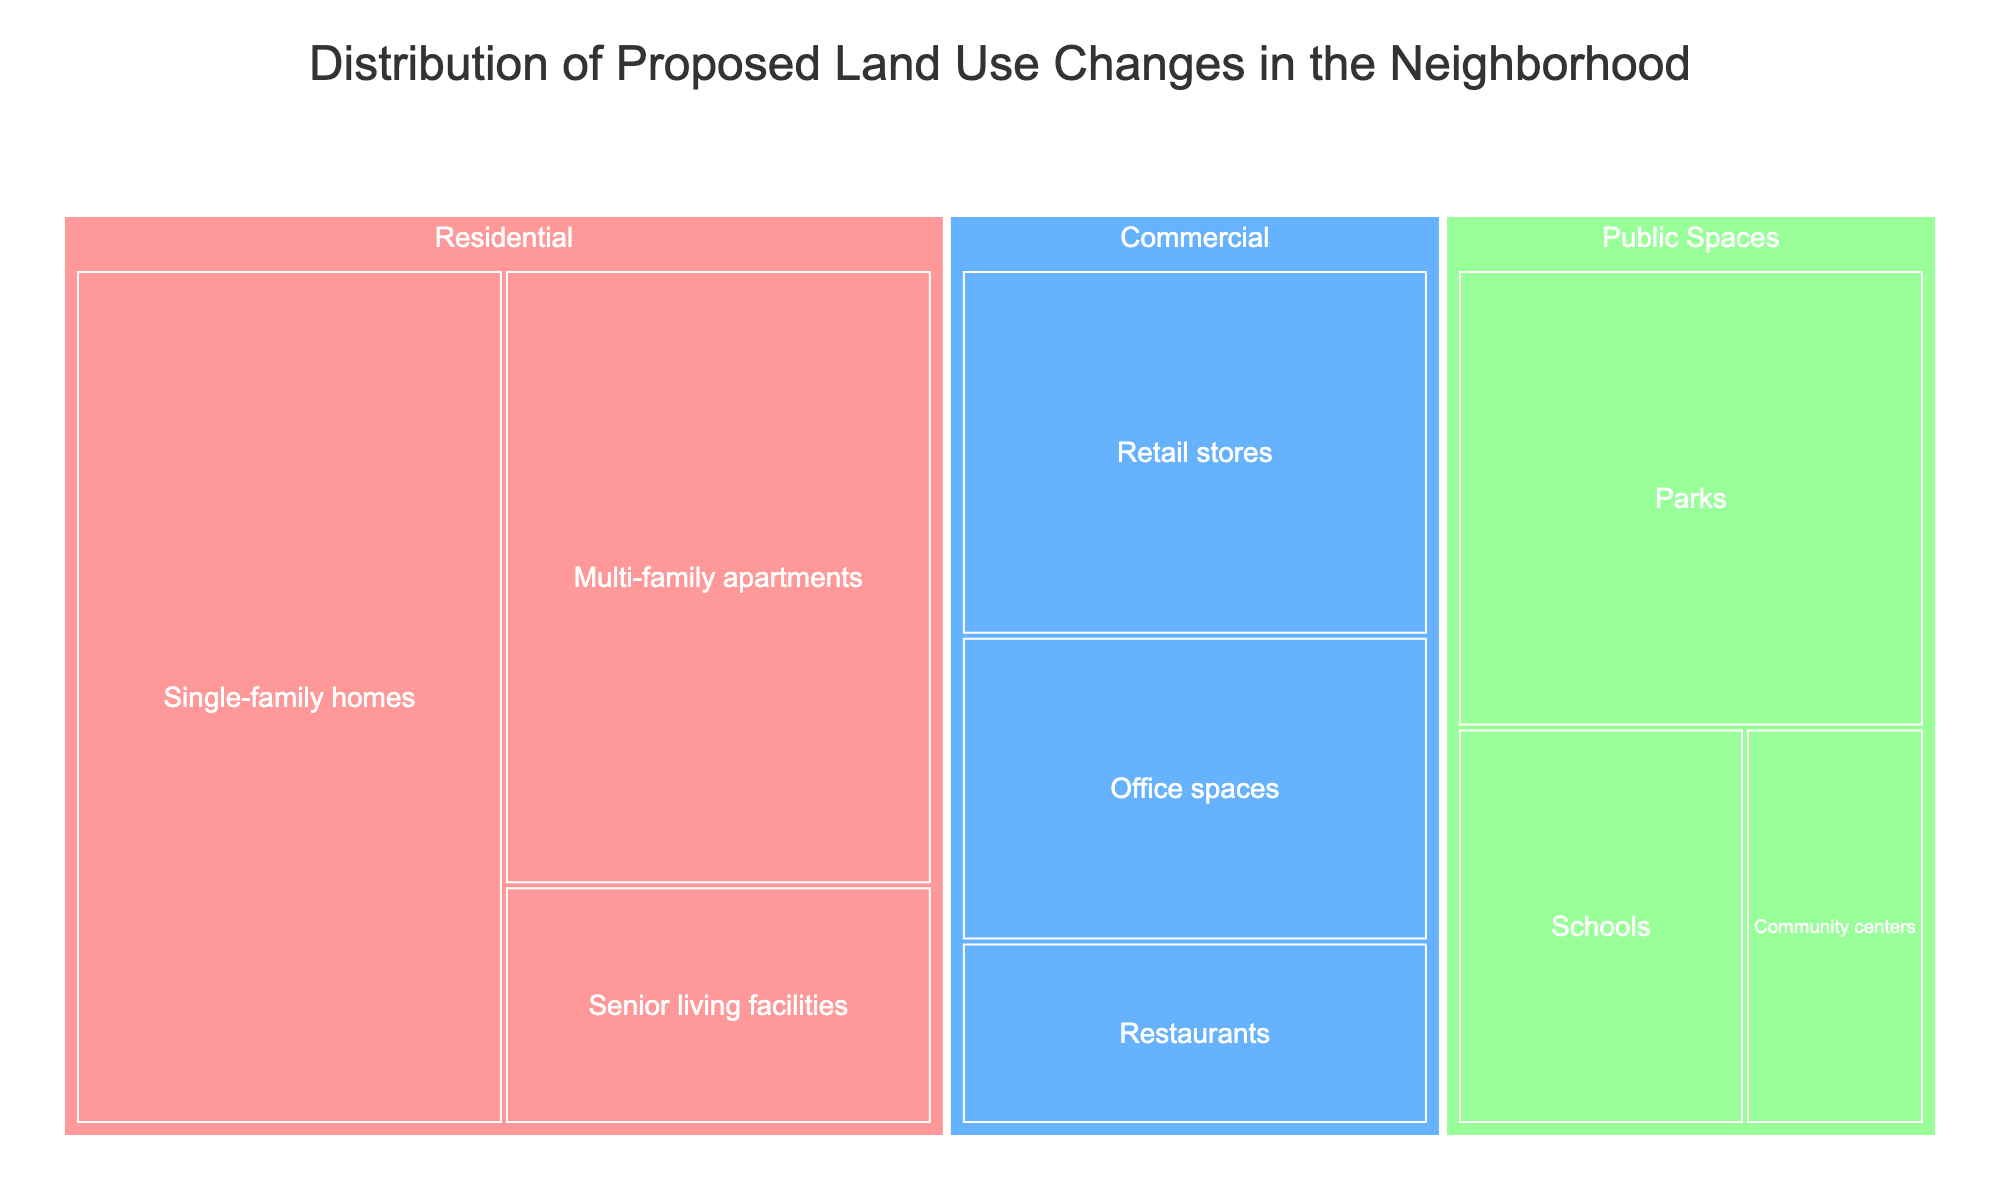What is the total area dedicated to commercial spaces? Sum the areas of all the commercial subcategories: Retail stores (120), Office spaces (100), and Restaurants (60): 120 + 100 + 60 = 280
Answer: 280 Which subcategory has the largest area in residential spaces? Among Single-family homes (250), Multi-family apartments (180), and Senior living facilities (70), the largest area is for Single-family homes.
Answer: Single-family homes What is the ratio of the total area of public spaces to residential spaces? First, find the total area of public spaces: Parks (150) + Community centers (50) + Schools (80) = 280. Then, find the total area of residential spaces: Single-family homes (250) + Multi-family apartments (180) + Senior living facilities (70) = 500. The ratio is 280 / 500 = 0.56.
Answer: 0.56 How does the area for parks compare to the area for schools in public spaces? Parks have an area of 150, and schools have an area of 80. 150 is greater than 80.
Answer: Parks have a larger area than schools What category has the smallest total area? Calculate the total for each category: Residential (500), Commercial (280), and Public Spaces (280). Both Commercial and Public Spaces are tied for the smallest area at 280 each.
Answer: Commercial and Public Spaces What percentage of the total area is dedicated to residential spaces? Total area across all categories is 500 (Residential) + 280 (Commercial) + 280 (Public Spaces) = 1060. Percentage for residential is (500 / 1060) * 100 ≈ 47.17%.
Answer: Approximately 47.17% Which category has more subcategories, commercial or public spaces? Commercial has 3 subcategories (Retail stores, Office spaces, Restaurants) and Public Spaces have 3 subcategories (Parks, Community centers, Schools). Both have the same number of subcategories.
Answer: Both have the same number How does the area for multi-family apartments compare to office spaces? Multi-family apartments have an area of 180, and office spaces have an area of 100. 180 is greater than 100.
Answer: Multi-family apartments have a larger area than office spaces What is the combined area of senior living facilities and community centers? Senior living facilities have an area of 70 and community centers have 50. The combined area is 70 + 50 = 120.
Answer: 120 What is the average area of subcategories within commercial spaces? Total area for Commercial is 280 with 3 subcategories. Average area is 280 / 3 ≈ 93.33.
Answer: Approximately 93.33 